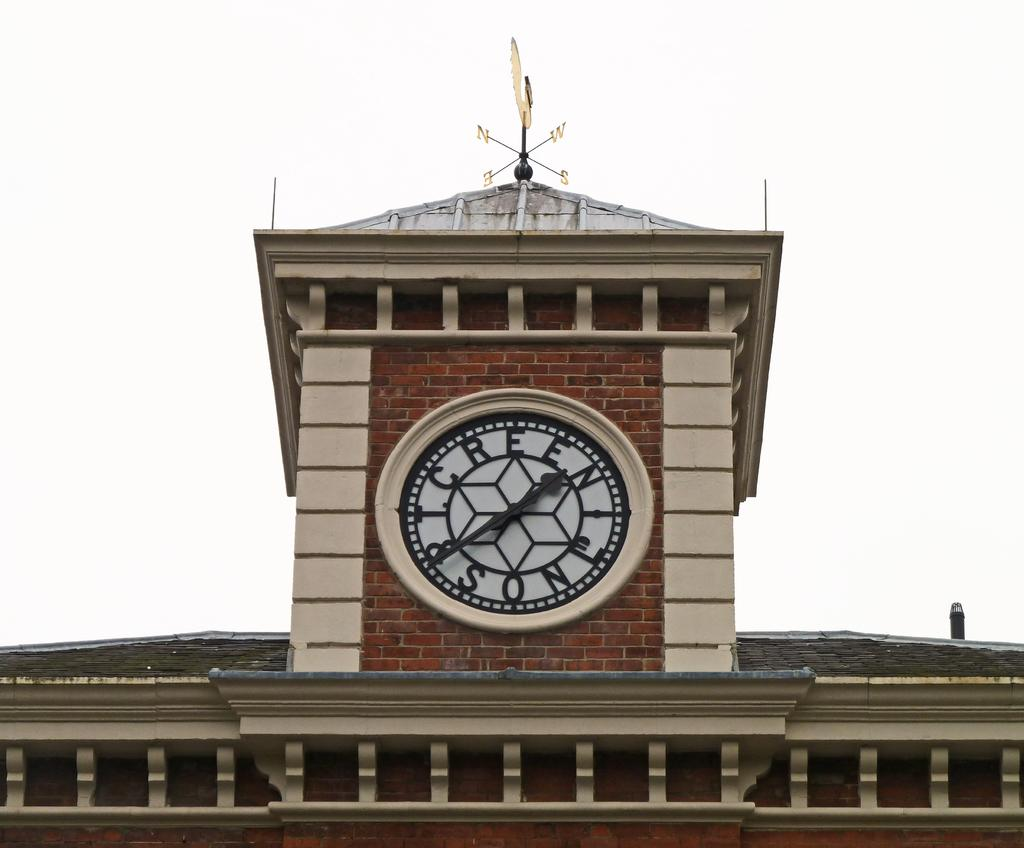<image>
Give a short and clear explanation of the subsequent image. A clock tower on a brick building with T. Green and Son on the clock. 